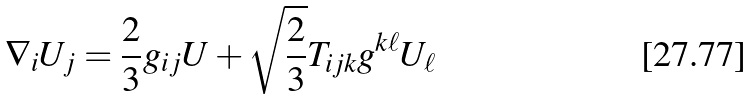<formula> <loc_0><loc_0><loc_500><loc_500>\nabla _ { i } U _ { j } = \frac { 2 } { 3 } g _ { i j } U + \sqrt { \frac { 2 } { 3 } } T _ { i j k } g ^ { k \ell } U _ { \ell }</formula> 